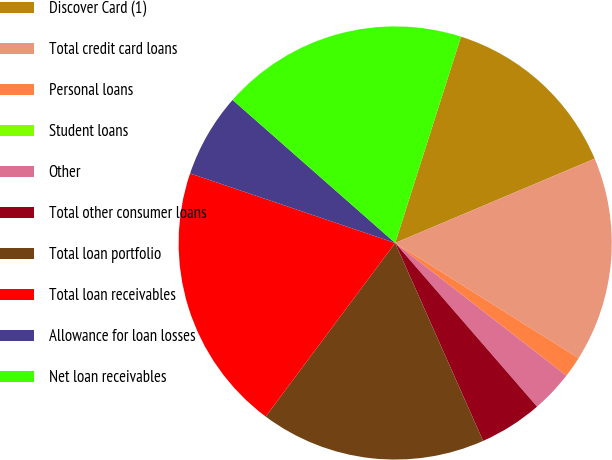Convert chart. <chart><loc_0><loc_0><loc_500><loc_500><pie_chart><fcel>Discover Card (1)<fcel>Total credit card loans<fcel>Personal loans<fcel>Student loans<fcel>Other<fcel>Total other consumer loans<fcel>Total loan portfolio<fcel>Total loan receivables<fcel>Allowance for loan losses<fcel>Net loan receivables<nl><fcel>13.72%<fcel>15.29%<fcel>1.57%<fcel>0.0%<fcel>3.14%<fcel>4.71%<fcel>16.86%<fcel>20.0%<fcel>6.28%<fcel>18.43%<nl></chart> 